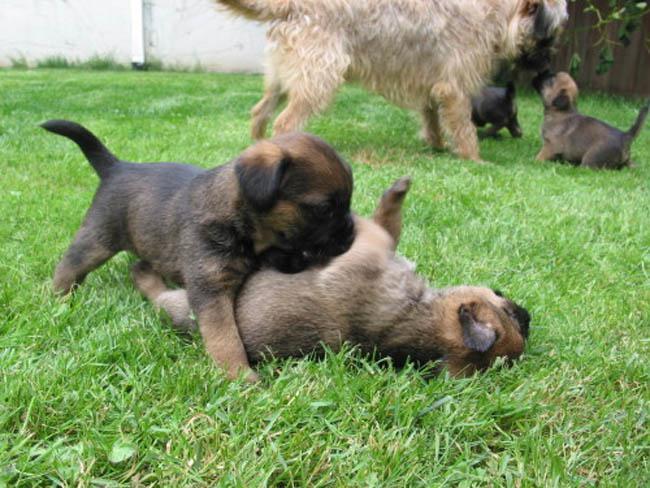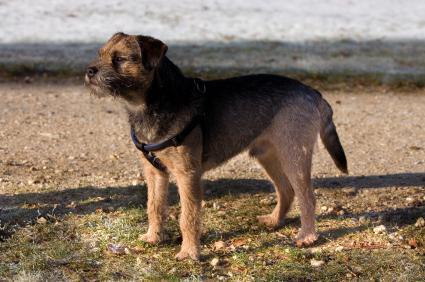The first image is the image on the left, the second image is the image on the right. For the images shown, is this caption "A single dog is standing alone in the grass in the image on the left." true? Answer yes or no. No. The first image is the image on the left, the second image is the image on the right. Examine the images to the left and right. Is the description "One image shows a dog standing wearing a harness and facing leftward." accurate? Answer yes or no. Yes. 